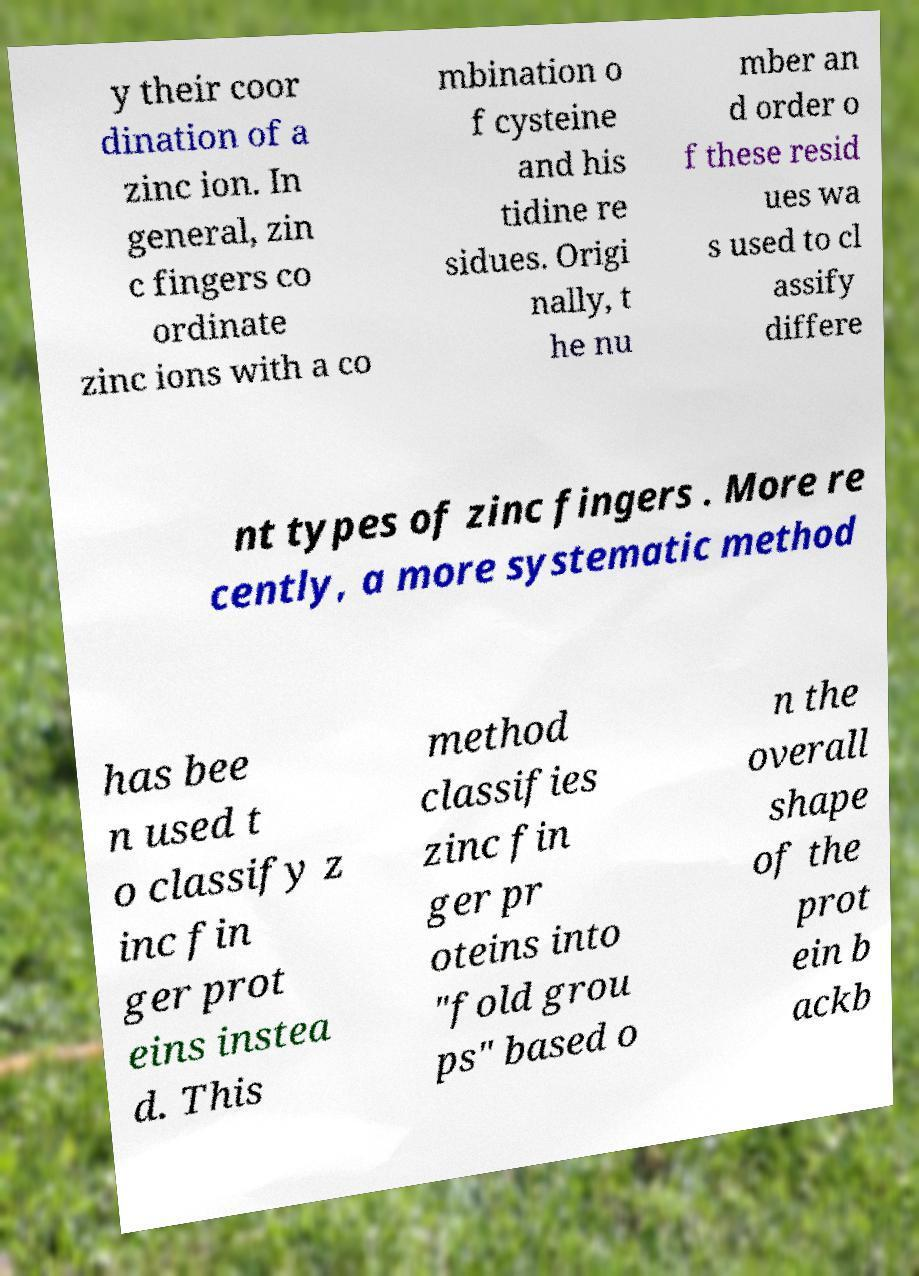Please read and relay the text visible in this image. What does it say? y their coor dination of a zinc ion. In general, zin c fingers co ordinate zinc ions with a co mbination o f cysteine and his tidine re sidues. Origi nally, t he nu mber an d order o f these resid ues wa s used to cl assify differe nt types of zinc fingers . More re cently, a more systematic method has bee n used t o classify z inc fin ger prot eins instea d. This method classifies zinc fin ger pr oteins into "fold grou ps" based o n the overall shape of the prot ein b ackb 